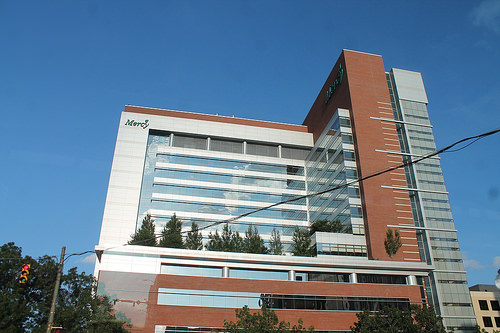<image>
Is the building behind the cable? Yes. From this viewpoint, the building is positioned behind the cable, with the cable partially or fully occluding the building. 